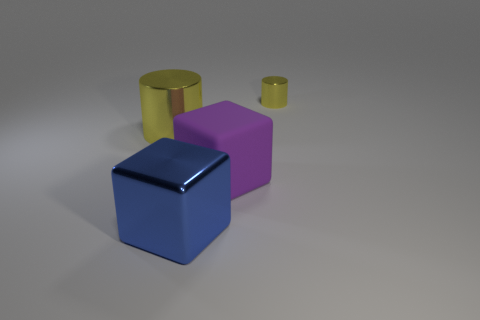What is the shape of the object that is the same color as the large metal cylinder?
Ensure brevity in your answer.  Cylinder. The blue block that is made of the same material as the large cylinder is what size?
Your answer should be compact. Large. Are there any big metallic cylinders of the same color as the large matte object?
Make the answer very short. No. Do the purple matte object and the yellow metallic cylinder right of the purple rubber object have the same size?
Provide a succinct answer. No. What number of yellow objects are behind the yellow metallic thing in front of the yellow metallic cylinder to the right of the large metallic cylinder?
Your answer should be very brief. 1. The other cylinder that is the same color as the tiny shiny cylinder is what size?
Offer a terse response. Large. Are there any tiny yellow metal cylinders on the right side of the big blue shiny thing?
Offer a terse response. Yes. What shape is the tiny shiny object?
Keep it short and to the point. Cylinder. There is a metal thing to the left of the metallic object that is in front of the yellow metallic object that is to the left of the tiny yellow object; what shape is it?
Provide a short and direct response. Cylinder. How many other objects are the same shape as the big blue object?
Offer a terse response. 1. 